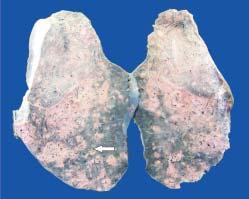does normal non-activated platelet, having open canalicular system and the cytoplasmic organelles show presence of minute millet-seed sized tubercles?
Answer the question using a single word or phrase. No 